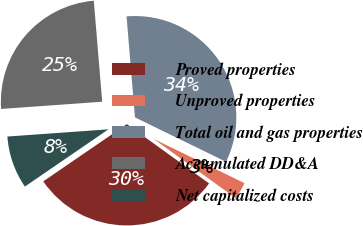Convert chart to OTSL. <chart><loc_0><loc_0><loc_500><loc_500><pie_chart><fcel>Proved properties<fcel>Unproved properties<fcel>Total oil and gas properties<fcel>Accumulated DD&A<fcel>Net capitalized costs<nl><fcel>30.49%<fcel>2.73%<fcel>33.54%<fcel>24.81%<fcel>8.42%<nl></chart> 